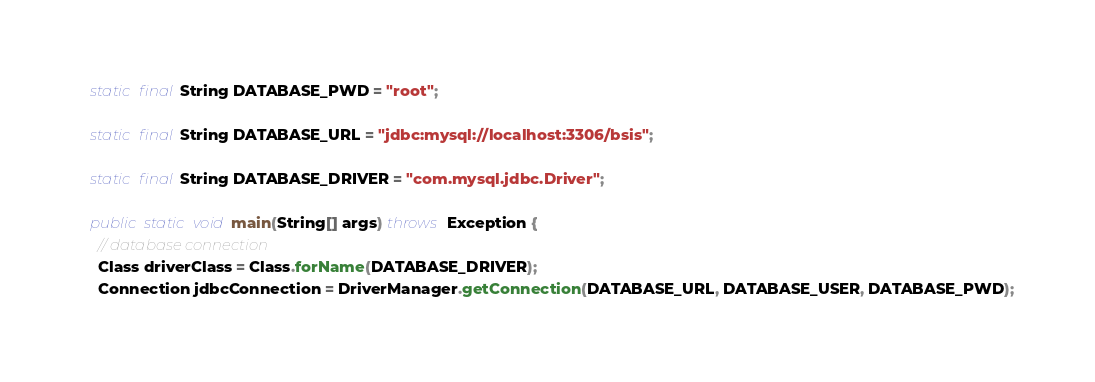<code> <loc_0><loc_0><loc_500><loc_500><_Java_>
  static final String DATABASE_PWD = "root";

  static final String DATABASE_URL = "jdbc:mysql://localhost:3306/bsis";

  static final String DATABASE_DRIVER = "com.mysql.jdbc.Driver";

  public static void main(String[] args) throws Exception {
    // database connection
    Class driverClass = Class.forName(DATABASE_DRIVER);
    Connection jdbcConnection = DriverManager.getConnection(DATABASE_URL, DATABASE_USER, DATABASE_PWD);</code> 